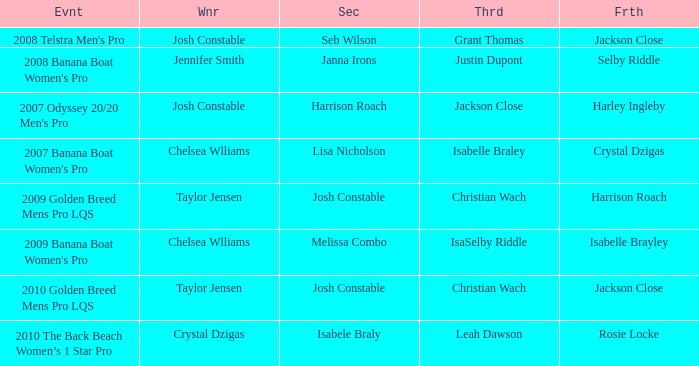Who was the Winner when Selby Riddle came in Fourth? Jennifer Smith. 